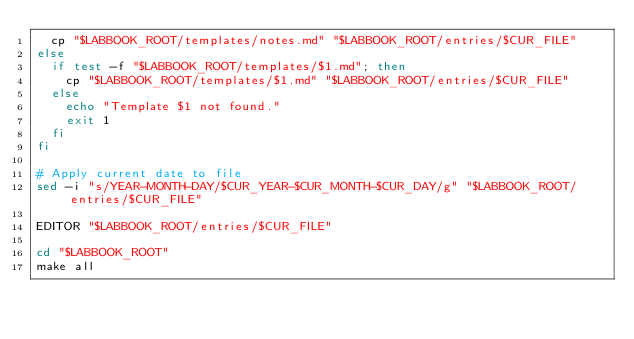<code> <loc_0><loc_0><loc_500><loc_500><_Bash_>	cp "$LABBOOK_ROOT/templates/notes.md" "$LABBOOK_ROOT/entries/$CUR_FILE"
else
	if test -f "$LABBOOK_ROOT/templates/$1.md"; then
		cp "$LABBOOK_ROOT/templates/$1.md" "$LABBOOK_ROOT/entries/$CUR_FILE"
	else
		echo "Template $1 not found."
		exit 1
	fi
fi

# Apply current date to file
sed -i "s/YEAR-MONTH-DAY/$CUR_YEAR-$CUR_MONTH-$CUR_DAY/g" "$LABBOOK_ROOT/entries/$CUR_FILE"

EDITOR "$LABBOOK_ROOT/entries/$CUR_FILE"

cd "$LABBOOK_ROOT"
make all
</code> 